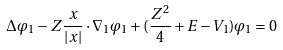Convert formula to latex. <formula><loc_0><loc_0><loc_500><loc_500>\Delta \varphi _ { 1 } - Z \frac { x } { | x | } \cdot \nabla _ { 1 } \varphi _ { 1 } + ( \frac { Z ^ { 2 } } { 4 } + E - V _ { 1 } ) \varphi _ { 1 } = 0</formula> 